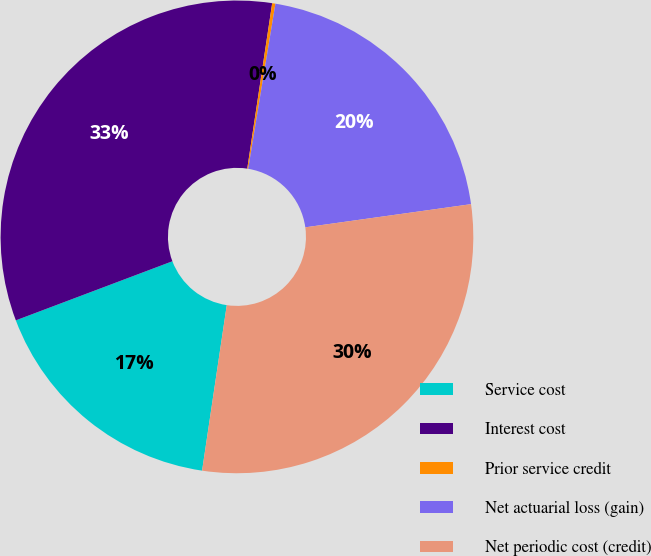Convert chart to OTSL. <chart><loc_0><loc_0><loc_500><loc_500><pie_chart><fcel>Service cost<fcel>Interest cost<fcel>Prior service credit<fcel>Net actuarial loss (gain)<fcel>Net periodic cost (credit)<nl><fcel>16.9%<fcel>33.13%<fcel>0.22%<fcel>20.19%<fcel>29.57%<nl></chart> 